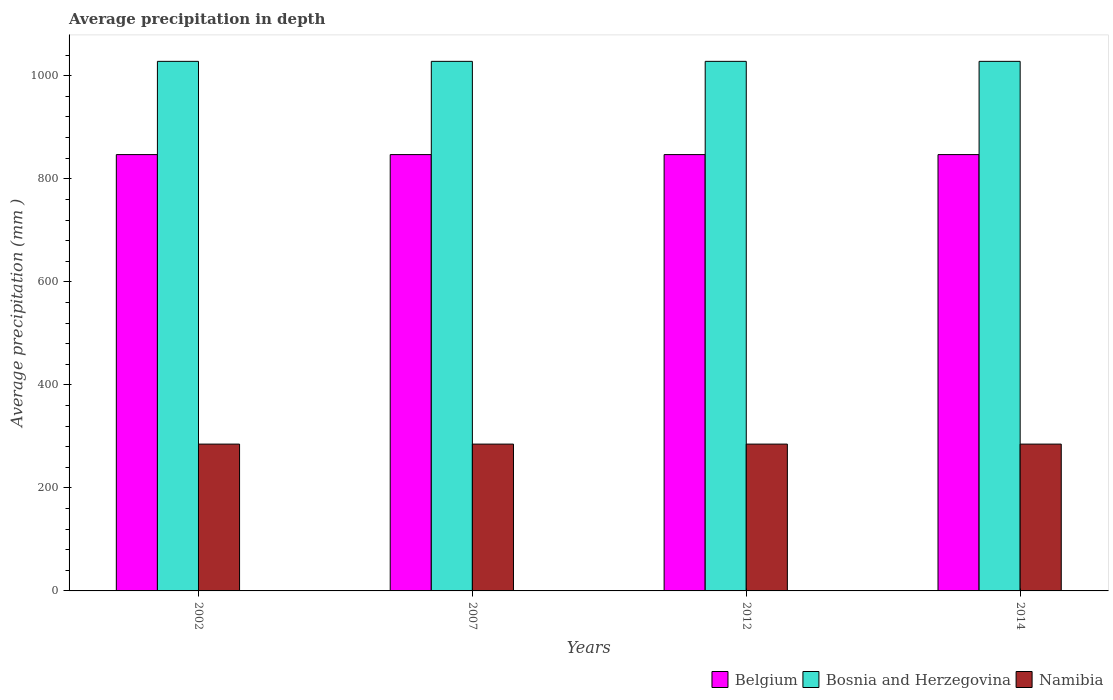Are the number of bars on each tick of the X-axis equal?
Ensure brevity in your answer.  Yes. How many bars are there on the 1st tick from the left?
Your answer should be very brief. 3. What is the label of the 2nd group of bars from the left?
Your answer should be very brief. 2007. In how many cases, is the number of bars for a given year not equal to the number of legend labels?
Your answer should be very brief. 0. What is the average precipitation in Belgium in 2014?
Make the answer very short. 847. Across all years, what is the maximum average precipitation in Namibia?
Your answer should be very brief. 285. Across all years, what is the minimum average precipitation in Namibia?
Offer a terse response. 285. In which year was the average precipitation in Belgium maximum?
Your answer should be compact. 2002. What is the total average precipitation in Belgium in the graph?
Provide a short and direct response. 3388. What is the difference between the average precipitation in Bosnia and Herzegovina in 2012 and that in 2014?
Your answer should be very brief. 0. What is the difference between the average precipitation in Namibia in 2007 and the average precipitation in Belgium in 2012?
Your answer should be very brief. -562. What is the average average precipitation in Bosnia and Herzegovina per year?
Your answer should be very brief. 1028. In the year 2014, what is the difference between the average precipitation in Belgium and average precipitation in Bosnia and Herzegovina?
Your answer should be very brief. -181. In how many years, is the average precipitation in Bosnia and Herzegovina greater than 120 mm?
Ensure brevity in your answer.  4. Is the difference between the average precipitation in Belgium in 2002 and 2014 greater than the difference between the average precipitation in Bosnia and Herzegovina in 2002 and 2014?
Your answer should be compact. No. What is the difference between the highest and the second highest average precipitation in Namibia?
Your answer should be compact. 0. What is the difference between the highest and the lowest average precipitation in Bosnia and Herzegovina?
Your response must be concise. 0. In how many years, is the average precipitation in Bosnia and Herzegovina greater than the average average precipitation in Bosnia and Herzegovina taken over all years?
Offer a terse response. 0. What does the 2nd bar from the right in 2002 represents?
Your answer should be very brief. Bosnia and Herzegovina. Is it the case that in every year, the sum of the average precipitation in Belgium and average precipitation in Namibia is greater than the average precipitation in Bosnia and Herzegovina?
Your answer should be very brief. Yes. How many bars are there?
Your response must be concise. 12. Does the graph contain any zero values?
Offer a terse response. No. How are the legend labels stacked?
Keep it short and to the point. Horizontal. What is the title of the graph?
Your answer should be compact. Average precipitation in depth. Does "Micronesia" appear as one of the legend labels in the graph?
Offer a very short reply. No. What is the label or title of the X-axis?
Your response must be concise. Years. What is the label or title of the Y-axis?
Make the answer very short. Average precipitation (mm ). What is the Average precipitation (mm ) of Belgium in 2002?
Keep it short and to the point. 847. What is the Average precipitation (mm ) in Bosnia and Herzegovina in 2002?
Provide a succinct answer. 1028. What is the Average precipitation (mm ) in Namibia in 2002?
Keep it short and to the point. 285. What is the Average precipitation (mm ) of Belgium in 2007?
Your answer should be compact. 847. What is the Average precipitation (mm ) in Bosnia and Herzegovina in 2007?
Offer a very short reply. 1028. What is the Average precipitation (mm ) of Namibia in 2007?
Your response must be concise. 285. What is the Average precipitation (mm ) in Belgium in 2012?
Offer a very short reply. 847. What is the Average precipitation (mm ) of Bosnia and Herzegovina in 2012?
Give a very brief answer. 1028. What is the Average precipitation (mm ) of Namibia in 2012?
Offer a very short reply. 285. What is the Average precipitation (mm ) of Belgium in 2014?
Ensure brevity in your answer.  847. What is the Average precipitation (mm ) of Bosnia and Herzegovina in 2014?
Give a very brief answer. 1028. What is the Average precipitation (mm ) of Namibia in 2014?
Offer a very short reply. 285. Across all years, what is the maximum Average precipitation (mm ) in Belgium?
Offer a very short reply. 847. Across all years, what is the maximum Average precipitation (mm ) of Bosnia and Herzegovina?
Provide a short and direct response. 1028. Across all years, what is the maximum Average precipitation (mm ) in Namibia?
Provide a succinct answer. 285. Across all years, what is the minimum Average precipitation (mm ) in Belgium?
Provide a succinct answer. 847. Across all years, what is the minimum Average precipitation (mm ) of Bosnia and Herzegovina?
Your answer should be very brief. 1028. Across all years, what is the minimum Average precipitation (mm ) in Namibia?
Your response must be concise. 285. What is the total Average precipitation (mm ) in Belgium in the graph?
Your answer should be very brief. 3388. What is the total Average precipitation (mm ) of Bosnia and Herzegovina in the graph?
Your answer should be very brief. 4112. What is the total Average precipitation (mm ) in Namibia in the graph?
Your response must be concise. 1140. What is the difference between the Average precipitation (mm ) in Belgium in 2002 and that in 2012?
Ensure brevity in your answer.  0. What is the difference between the Average precipitation (mm ) in Belgium in 2002 and that in 2014?
Your response must be concise. 0. What is the difference between the Average precipitation (mm ) of Bosnia and Herzegovina in 2002 and that in 2014?
Keep it short and to the point. 0. What is the difference between the Average precipitation (mm ) in Namibia in 2002 and that in 2014?
Provide a succinct answer. 0. What is the difference between the Average precipitation (mm ) of Belgium in 2007 and that in 2012?
Keep it short and to the point. 0. What is the difference between the Average precipitation (mm ) of Bosnia and Herzegovina in 2007 and that in 2012?
Your response must be concise. 0. What is the difference between the Average precipitation (mm ) in Namibia in 2007 and that in 2012?
Ensure brevity in your answer.  0. What is the difference between the Average precipitation (mm ) of Belgium in 2007 and that in 2014?
Ensure brevity in your answer.  0. What is the difference between the Average precipitation (mm ) of Bosnia and Herzegovina in 2007 and that in 2014?
Your response must be concise. 0. What is the difference between the Average precipitation (mm ) of Namibia in 2007 and that in 2014?
Your response must be concise. 0. What is the difference between the Average precipitation (mm ) in Belgium in 2012 and that in 2014?
Provide a short and direct response. 0. What is the difference between the Average precipitation (mm ) of Belgium in 2002 and the Average precipitation (mm ) of Bosnia and Herzegovina in 2007?
Offer a terse response. -181. What is the difference between the Average precipitation (mm ) of Belgium in 2002 and the Average precipitation (mm ) of Namibia in 2007?
Keep it short and to the point. 562. What is the difference between the Average precipitation (mm ) of Bosnia and Herzegovina in 2002 and the Average precipitation (mm ) of Namibia in 2007?
Give a very brief answer. 743. What is the difference between the Average precipitation (mm ) in Belgium in 2002 and the Average precipitation (mm ) in Bosnia and Herzegovina in 2012?
Your answer should be compact. -181. What is the difference between the Average precipitation (mm ) of Belgium in 2002 and the Average precipitation (mm ) of Namibia in 2012?
Provide a succinct answer. 562. What is the difference between the Average precipitation (mm ) of Bosnia and Herzegovina in 2002 and the Average precipitation (mm ) of Namibia in 2012?
Your answer should be very brief. 743. What is the difference between the Average precipitation (mm ) in Belgium in 2002 and the Average precipitation (mm ) in Bosnia and Herzegovina in 2014?
Offer a very short reply. -181. What is the difference between the Average precipitation (mm ) of Belgium in 2002 and the Average precipitation (mm ) of Namibia in 2014?
Offer a very short reply. 562. What is the difference between the Average precipitation (mm ) in Bosnia and Herzegovina in 2002 and the Average precipitation (mm ) in Namibia in 2014?
Provide a short and direct response. 743. What is the difference between the Average precipitation (mm ) in Belgium in 2007 and the Average precipitation (mm ) in Bosnia and Herzegovina in 2012?
Make the answer very short. -181. What is the difference between the Average precipitation (mm ) in Belgium in 2007 and the Average precipitation (mm ) in Namibia in 2012?
Ensure brevity in your answer.  562. What is the difference between the Average precipitation (mm ) in Bosnia and Herzegovina in 2007 and the Average precipitation (mm ) in Namibia in 2012?
Your response must be concise. 743. What is the difference between the Average precipitation (mm ) in Belgium in 2007 and the Average precipitation (mm ) in Bosnia and Herzegovina in 2014?
Provide a short and direct response. -181. What is the difference between the Average precipitation (mm ) of Belgium in 2007 and the Average precipitation (mm ) of Namibia in 2014?
Keep it short and to the point. 562. What is the difference between the Average precipitation (mm ) in Bosnia and Herzegovina in 2007 and the Average precipitation (mm ) in Namibia in 2014?
Give a very brief answer. 743. What is the difference between the Average precipitation (mm ) in Belgium in 2012 and the Average precipitation (mm ) in Bosnia and Herzegovina in 2014?
Your answer should be compact. -181. What is the difference between the Average precipitation (mm ) of Belgium in 2012 and the Average precipitation (mm ) of Namibia in 2014?
Ensure brevity in your answer.  562. What is the difference between the Average precipitation (mm ) of Bosnia and Herzegovina in 2012 and the Average precipitation (mm ) of Namibia in 2014?
Your response must be concise. 743. What is the average Average precipitation (mm ) in Belgium per year?
Keep it short and to the point. 847. What is the average Average precipitation (mm ) in Bosnia and Herzegovina per year?
Your answer should be very brief. 1028. What is the average Average precipitation (mm ) of Namibia per year?
Your answer should be compact. 285. In the year 2002, what is the difference between the Average precipitation (mm ) of Belgium and Average precipitation (mm ) of Bosnia and Herzegovina?
Your answer should be compact. -181. In the year 2002, what is the difference between the Average precipitation (mm ) of Belgium and Average precipitation (mm ) of Namibia?
Offer a very short reply. 562. In the year 2002, what is the difference between the Average precipitation (mm ) in Bosnia and Herzegovina and Average precipitation (mm ) in Namibia?
Keep it short and to the point. 743. In the year 2007, what is the difference between the Average precipitation (mm ) of Belgium and Average precipitation (mm ) of Bosnia and Herzegovina?
Ensure brevity in your answer.  -181. In the year 2007, what is the difference between the Average precipitation (mm ) of Belgium and Average precipitation (mm ) of Namibia?
Provide a succinct answer. 562. In the year 2007, what is the difference between the Average precipitation (mm ) of Bosnia and Herzegovina and Average precipitation (mm ) of Namibia?
Keep it short and to the point. 743. In the year 2012, what is the difference between the Average precipitation (mm ) of Belgium and Average precipitation (mm ) of Bosnia and Herzegovina?
Ensure brevity in your answer.  -181. In the year 2012, what is the difference between the Average precipitation (mm ) of Belgium and Average precipitation (mm ) of Namibia?
Provide a short and direct response. 562. In the year 2012, what is the difference between the Average precipitation (mm ) of Bosnia and Herzegovina and Average precipitation (mm ) of Namibia?
Keep it short and to the point. 743. In the year 2014, what is the difference between the Average precipitation (mm ) of Belgium and Average precipitation (mm ) of Bosnia and Herzegovina?
Offer a terse response. -181. In the year 2014, what is the difference between the Average precipitation (mm ) in Belgium and Average precipitation (mm ) in Namibia?
Provide a succinct answer. 562. In the year 2014, what is the difference between the Average precipitation (mm ) of Bosnia and Herzegovina and Average precipitation (mm ) of Namibia?
Ensure brevity in your answer.  743. What is the ratio of the Average precipitation (mm ) of Belgium in 2002 to that in 2007?
Your answer should be very brief. 1. What is the ratio of the Average precipitation (mm ) of Belgium in 2002 to that in 2012?
Your answer should be very brief. 1. What is the ratio of the Average precipitation (mm ) of Bosnia and Herzegovina in 2002 to that in 2012?
Offer a very short reply. 1. What is the ratio of the Average precipitation (mm ) of Bosnia and Herzegovina in 2002 to that in 2014?
Ensure brevity in your answer.  1. What is the ratio of the Average precipitation (mm ) in Namibia in 2002 to that in 2014?
Your response must be concise. 1. What is the ratio of the Average precipitation (mm ) of Belgium in 2007 to that in 2012?
Offer a terse response. 1. What is the ratio of the Average precipitation (mm ) of Namibia in 2007 to that in 2012?
Provide a short and direct response. 1. What is the ratio of the Average precipitation (mm ) of Belgium in 2007 to that in 2014?
Give a very brief answer. 1. What is the ratio of the Average precipitation (mm ) of Bosnia and Herzegovina in 2007 to that in 2014?
Ensure brevity in your answer.  1. What is the ratio of the Average precipitation (mm ) in Namibia in 2012 to that in 2014?
Offer a very short reply. 1. What is the difference between the highest and the second highest Average precipitation (mm ) in Bosnia and Herzegovina?
Your response must be concise. 0. 